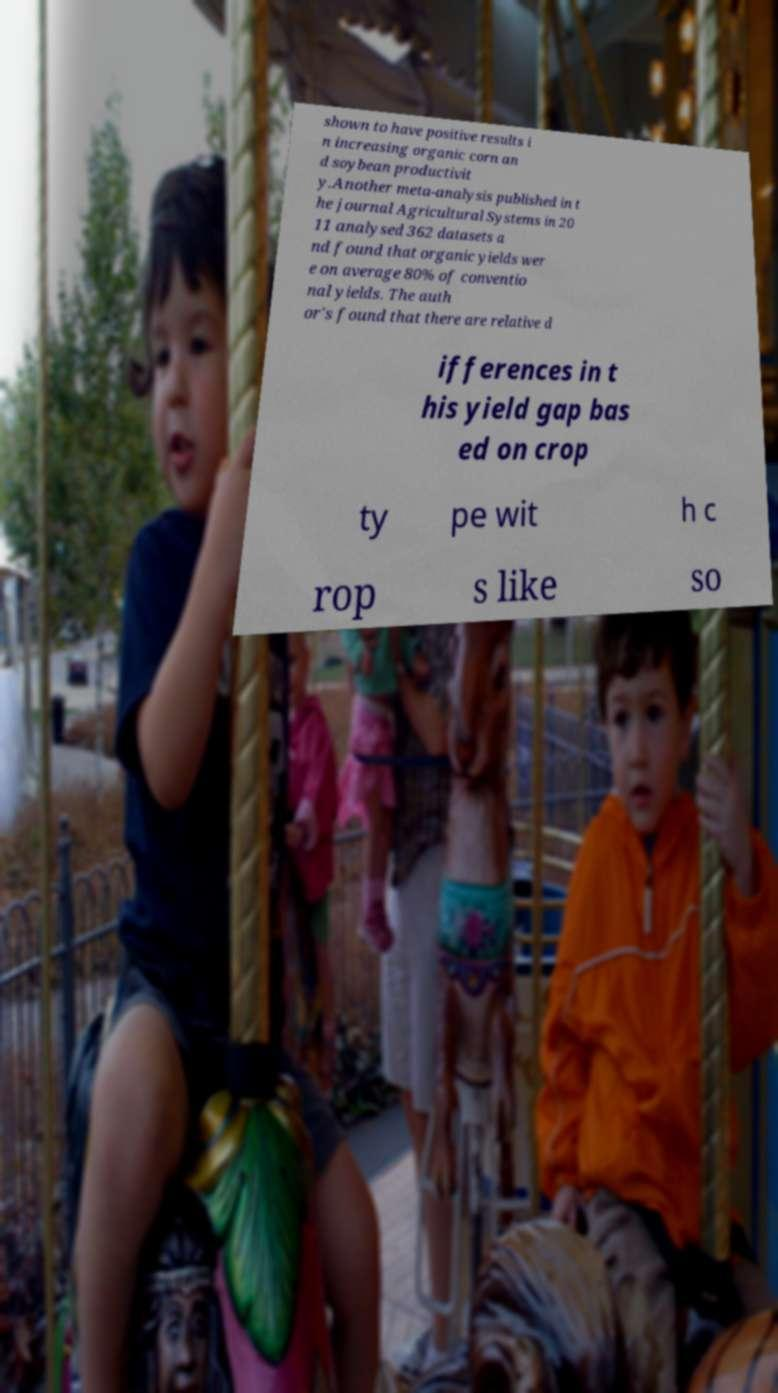For documentation purposes, I need the text within this image transcribed. Could you provide that? shown to have positive results i n increasing organic corn an d soybean productivit y.Another meta-analysis published in t he journal Agricultural Systems in 20 11 analysed 362 datasets a nd found that organic yields wer e on average 80% of conventio nal yields. The auth or's found that there are relative d ifferences in t his yield gap bas ed on crop ty pe wit h c rop s like so 